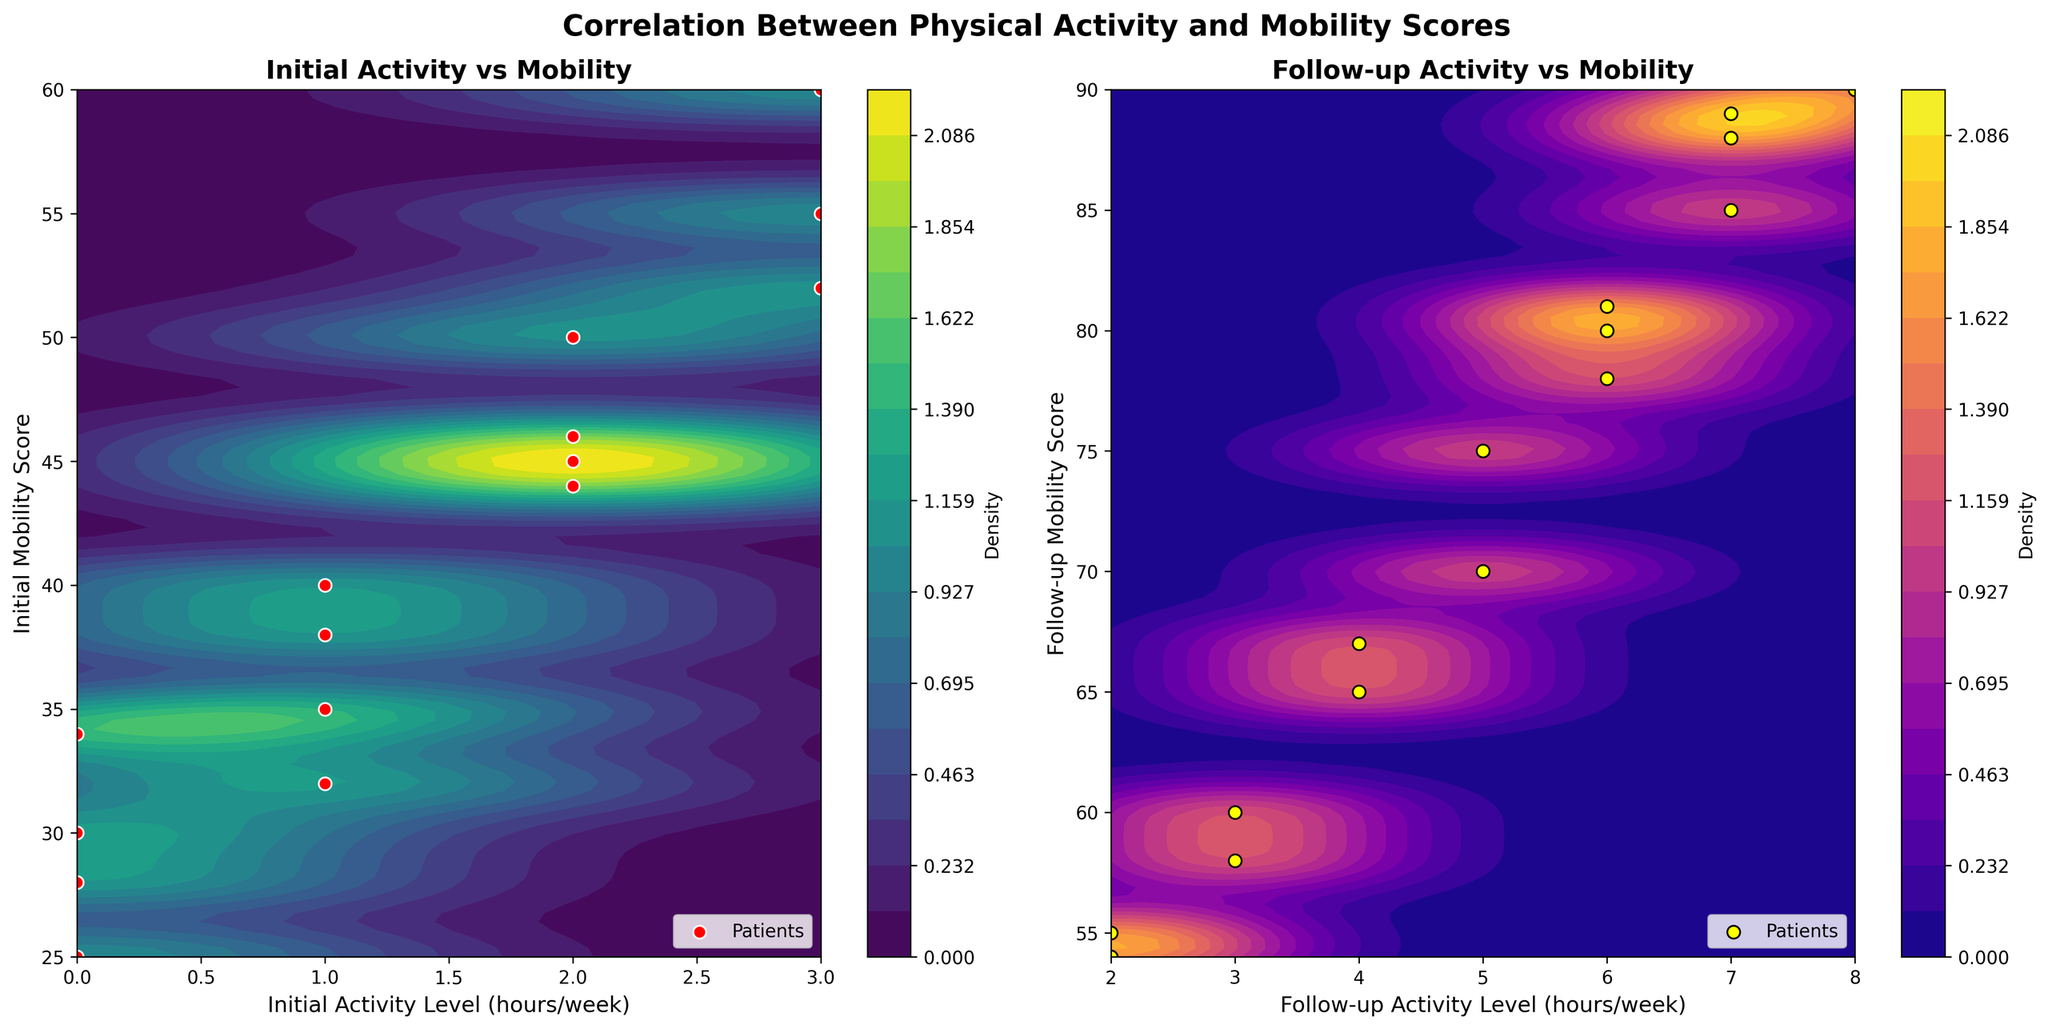What does the title of the overall figure indicate? The overall title of the figure reads "Correlation Between Physical Activity and Mobility Scores," which indicates that the figure is exploring the relationship between physical activity levels and mobility scores in patients.
Answer: Correlation Between Physical Activity and Mobility Scores Which axis represents the Initial Activity Level in the first subplot? The x-axis in the first subplot represents the Initial Activity Level (hours/week).
Answer: x-axis How many patients had an Initial Activity Level of 3 hours/week? In the first subplot, there are two red data points at the x-value of 3 hours/week, showing that there are two patients with this Initial Activity Level.
Answer: Two What colors are used to denote the data points in the first and second subplots, respectively? The data points in the first subplot are red with a white edge, and the data points in the second subplot are yellow with a black edge.
Answer: Red with white edge (first), yellow with black edge (second) Which subplot has a higher maximum density level? The second subplot on the right has the higher maximum density level, as indicated by the brighter regions in the contour.
Answer: Second subplot Compare the median Follow-up Mobility Score with the median Initial Mobility Score. Which one is higher? To find the median, we'll sort the Follow-up Mobility Scores (55, 54, 58, 60, 65, 67, 70, 75, 78, 80, 81, 85, 88, 89, 90) and the Initial Mobility Scores (25, 28, 30, 32, 34, 35, 38, 40, 44, 45, 46, 50, 52, 55, 60). The median value for Follow-up Mobility Score is 70. The median value for Initial Mobility Score is 38. Therefore, the median Follow-up Mobility Score is higher.
Answer: Follow-up Is there a noticeable trend between Follow-up Activity Level and Follow-up Mobility Score? The scatter plot in the second subplot, along with the density contours, shows a positive trend between Follow-up Activity Level and Follow-up Mobility Score, indicating that higher activity levels correlate with higher mobility scores.
Answer: Yes Do more patients fall in the higher or lower density regions in the Initial Activity vs Mobility plot? In the first subplot, more patients fall in the higher density regions, as shown by the concentration of red points within the brighter areas of the contour plot.
Answer: Higher density regions What is the Follow-up Mobility Score range where most patients' data points are concentrated in the second subplot? In the second subplot, most patients' data points are concentrated in the Follow-up Mobility Score range of approximately 70 to 90.
Answer: 70 to 90 What is the contour color scheme used in the first subplot? The contour color scheme used in the first subplot is 'viridis,' which transitions from dark blue to yellow.
Answer: Viridis 